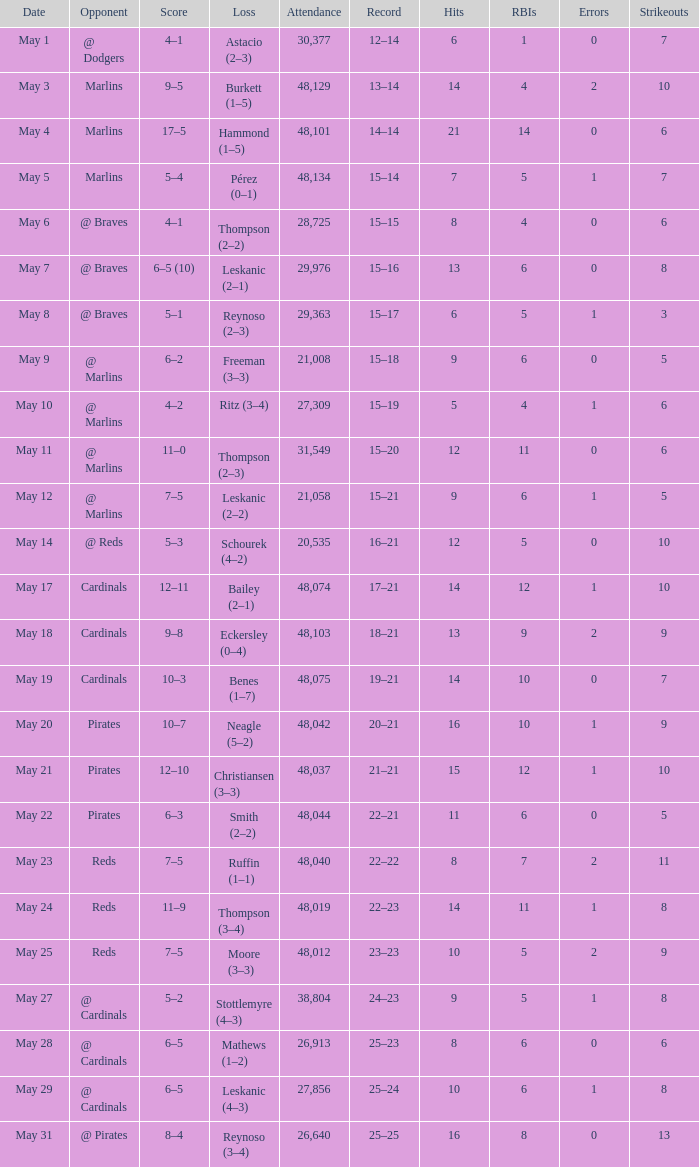Who did the Rockies play at the game that had a score of 6–5 (10)? @ Braves. 